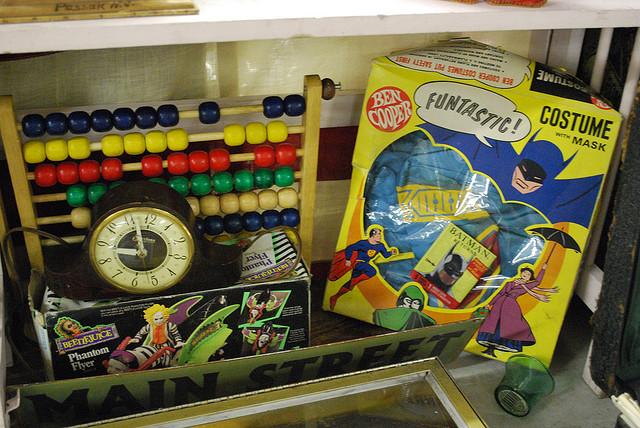What time does the clock show?
Quick response, please. 8:56. What is Batman saying?
Keep it brief. Funtastic. What characters are on the costume box?
Be succinct. Batman. 